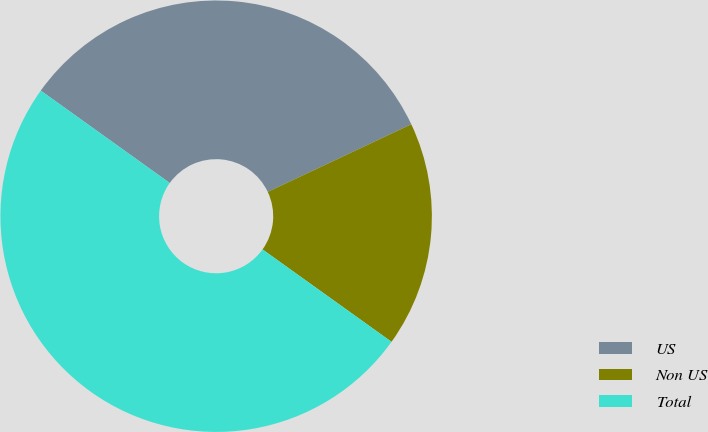Convert chart. <chart><loc_0><loc_0><loc_500><loc_500><pie_chart><fcel>US<fcel>Non US<fcel>Total<nl><fcel>33.1%<fcel>16.9%<fcel>50.0%<nl></chart> 